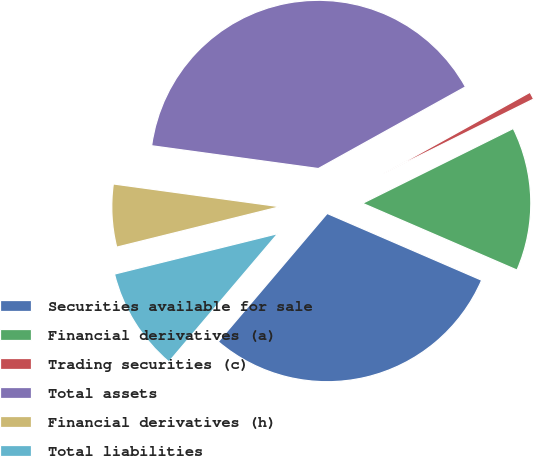Convert chart to OTSL. <chart><loc_0><loc_0><loc_500><loc_500><pie_chart><fcel>Securities available for sale<fcel>Financial derivatives (a)<fcel>Trading securities (c)<fcel>Total assets<fcel>Financial derivatives (h)<fcel>Total liabilities<nl><fcel>29.71%<fcel>13.83%<fcel>0.73%<fcel>39.77%<fcel>6.03%<fcel>9.93%<nl></chart> 